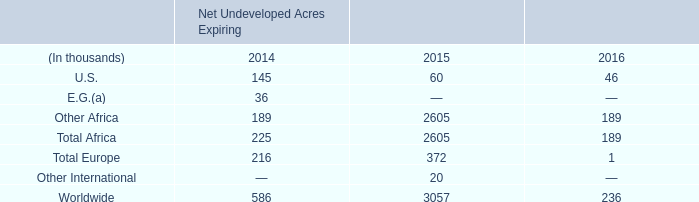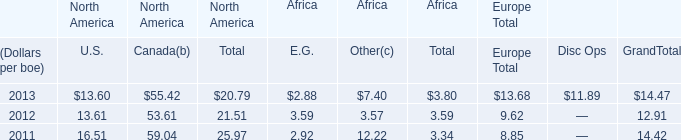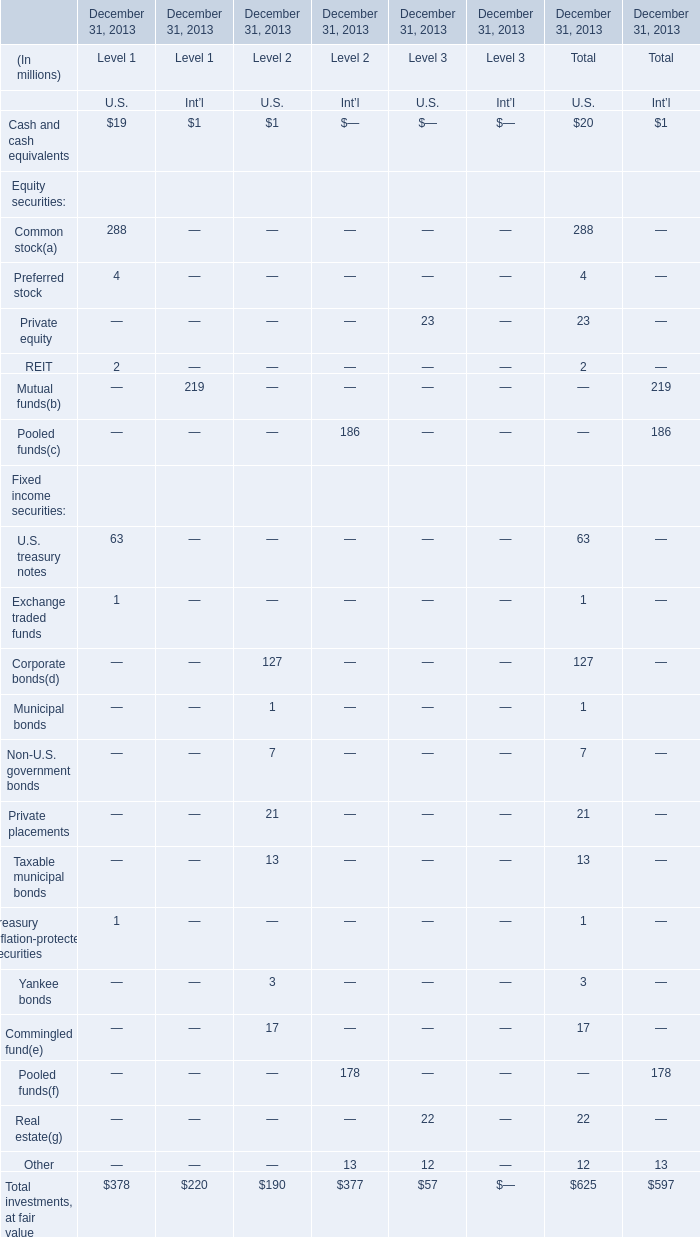What's the sum of all elements that are positive for U.S. of Level 2? (in million) 
Computations: (((((((1 + 127) + 1) + 7) + 21) + 13) + 3) + 17)
Answer: 190.0. 